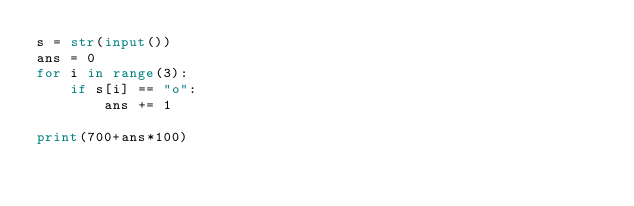<code> <loc_0><loc_0><loc_500><loc_500><_Python_>s = str(input())
ans = 0
for i in range(3):
    if s[i] == "o":
        ans += 1

print(700+ans*100)</code> 